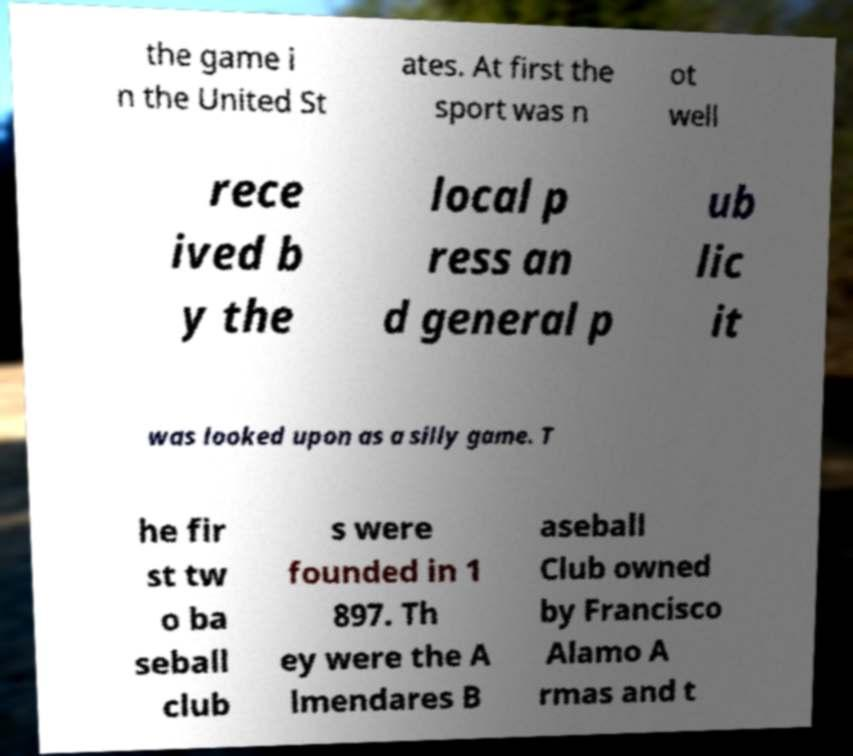For documentation purposes, I need the text within this image transcribed. Could you provide that? the game i n the United St ates. At first the sport was n ot well rece ived b y the local p ress an d general p ub lic it was looked upon as a silly game. T he fir st tw o ba seball club s were founded in 1 897. Th ey were the A lmendares B aseball Club owned by Francisco Alamo A rmas and t 